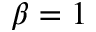<formula> <loc_0><loc_0><loc_500><loc_500>\beta = 1</formula> 